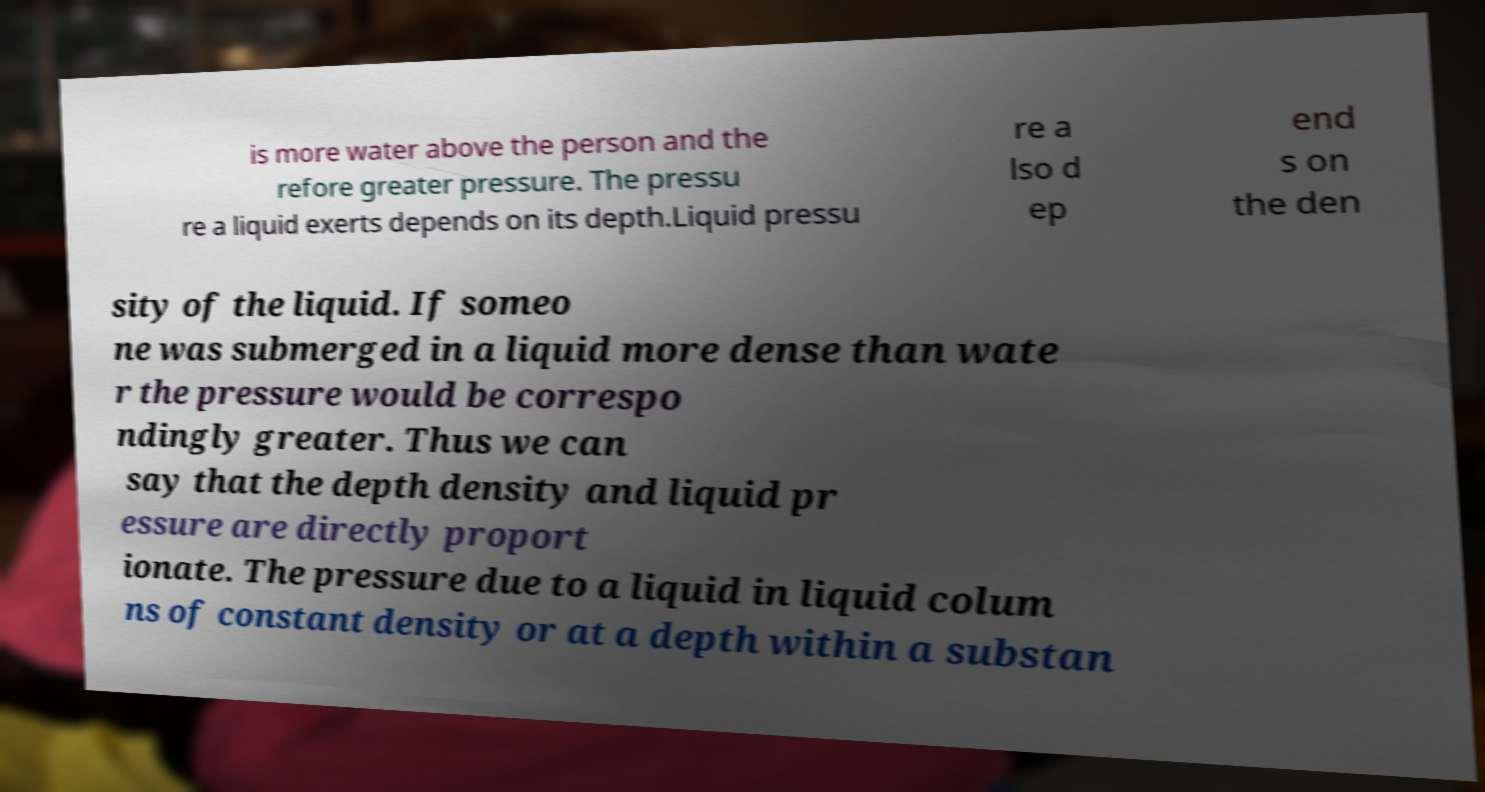There's text embedded in this image that I need extracted. Can you transcribe it verbatim? is more water above the person and the refore greater pressure. The pressu re a liquid exerts depends on its depth.Liquid pressu re a lso d ep end s on the den sity of the liquid. If someo ne was submerged in a liquid more dense than wate r the pressure would be correspo ndingly greater. Thus we can say that the depth density and liquid pr essure are directly proport ionate. The pressure due to a liquid in liquid colum ns of constant density or at a depth within a substan 